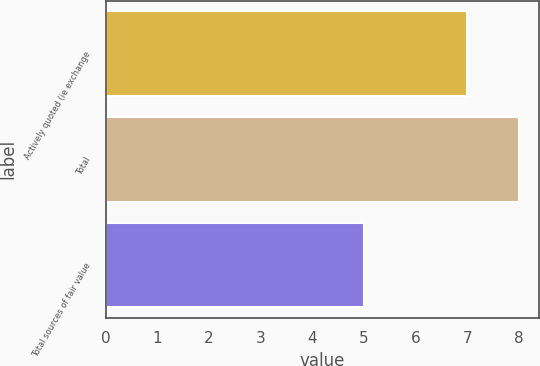Convert chart to OTSL. <chart><loc_0><loc_0><loc_500><loc_500><bar_chart><fcel>Actively quoted (ie exchange<fcel>Total<fcel>Total sources of fair value<nl><fcel>7<fcel>8<fcel>5<nl></chart> 